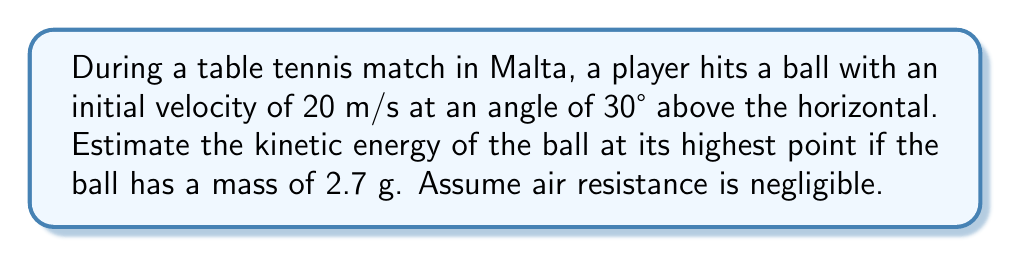What is the answer to this math problem? To solve this problem, we'll follow these steps:

1) First, recall the formula for kinetic energy:
   $$KE = \frac{1}{2}mv^2$$
   where $m$ is the mass and $v$ is the velocity.

2) We need to find the velocity at the highest point. At this point, the vertical component of velocity is zero, so we only need to consider the horizontal component.

3) The initial velocity components are:
   $$v_x = v_0 \cos \theta = 20 \cos 30° = 17.32 \text{ m/s}$$
   $$v_y = v_0 \sin \theta = 20 \sin 30° = 10 \text{ m/s}$$

4) At the highest point, $v_y = 0$, so the velocity is equal to $v_x = 17.32 \text{ m/s}$.

5) Now we can calculate the kinetic energy:
   $$KE = \frac{1}{2} (0.0027 \text{ kg}) (17.32 \text{ m/s})^2 = 0.405 \text{ J}$$

6) Converting to a more appropriate unit for table tennis:
   $$KE = 0.405 \text{ J} = 405 \text{ mJ}$$
Answer: 405 mJ 